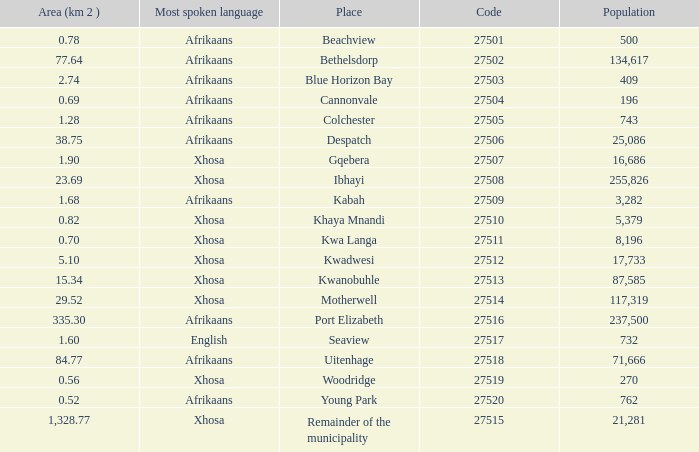What is the place that speaks xhosa, has a population less than 87,585, an area smaller than 1.28 squared kilometers, and a code larger than 27504? Khaya Mnandi, Kwa Langa, Woodridge. 